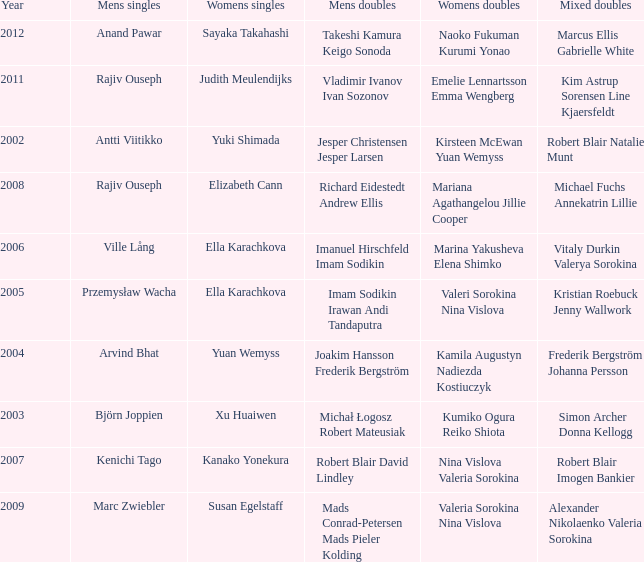What are the womens singles of naoko fukuman kurumi yonao? Sayaka Takahashi. 